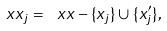<formula> <loc_0><loc_0><loc_500><loc_500>\ x x _ { j } = \ x x - \{ x _ { j } \} \cup \{ x ^ { \prime } _ { j } \} ,</formula> 